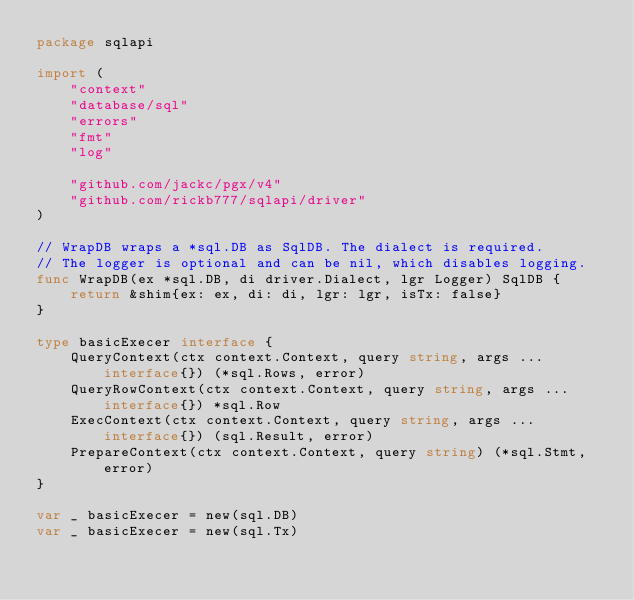<code> <loc_0><loc_0><loc_500><loc_500><_Go_>package sqlapi

import (
	"context"
	"database/sql"
	"errors"
	"fmt"
	"log"

	"github.com/jackc/pgx/v4"
	"github.com/rickb777/sqlapi/driver"
)

// WrapDB wraps a *sql.DB as SqlDB. The dialect is required.
// The logger is optional and can be nil, which disables logging.
func WrapDB(ex *sql.DB, di driver.Dialect, lgr Logger) SqlDB {
	return &shim{ex: ex, di: di, lgr: lgr, isTx: false}
}

type basicExecer interface {
	QueryContext(ctx context.Context, query string, args ...interface{}) (*sql.Rows, error)
	QueryRowContext(ctx context.Context, query string, args ...interface{}) *sql.Row
	ExecContext(ctx context.Context, query string, args ...interface{}) (sql.Result, error)
	PrepareContext(ctx context.Context, query string) (*sql.Stmt, error)
}

var _ basicExecer = new(sql.DB)
var _ basicExecer = new(sql.Tx)
</code> 